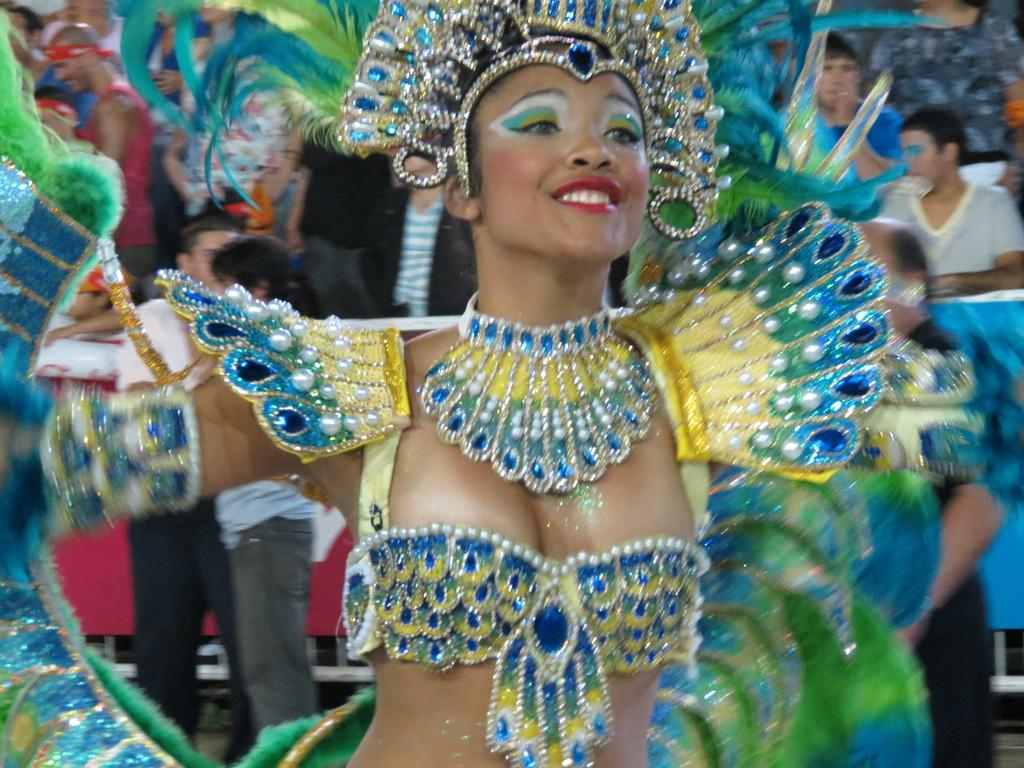How many people are in the image? There are people in the image, but the exact number is not specified. What is the woman wearing in the image? The woman is wearing a costume in the image. Can you describe the background of the image? The background of the image is blurry. What type of blood is visible on the growth in the image? There is no blood or growth present in the image. 